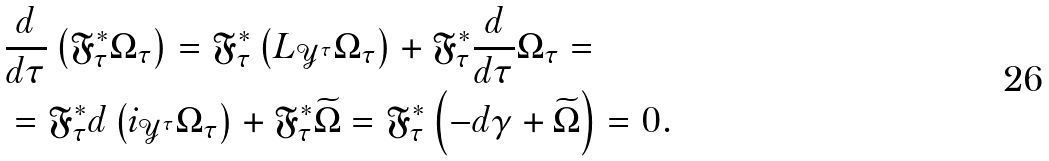Convert formula to latex. <formula><loc_0><loc_0><loc_500><loc_500>& \frac { d } { d \tau } \left ( \mathfrak { F } _ { \tau } ^ { * } \Omega _ { \tau } \right ) = \mathfrak { F } _ { \tau } ^ { * } \left ( L _ { \mathcal { Y } ^ { \tau } } \Omega _ { \tau } \right ) + \mathfrak { F } _ { \tau } ^ { * } \frac { d } { d \tau } \Omega _ { \tau } = \\ & = \mathfrak { F } _ { \tau } ^ { * } d \left ( i _ { \mathcal { Y } ^ { \tau } } \Omega _ { \tau } \right ) + \mathfrak { F } _ { \tau } ^ { * } \widetilde { \Omega } = \mathfrak { F } _ { \tau } ^ { * } \left ( - d \gamma + \widetilde { \Omega } \right ) = 0 .</formula> 